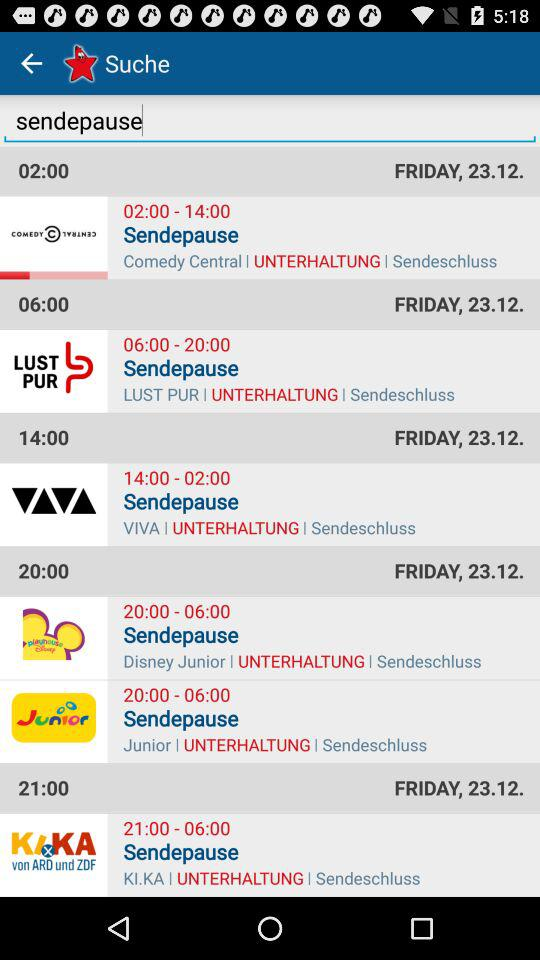What is the time for "Disney Junior"? The time for "Disney Junior" is 20:00–06:00. 